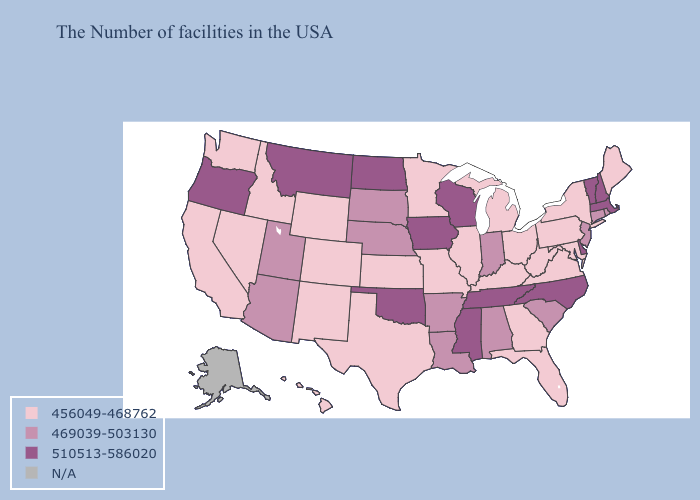Name the states that have a value in the range 510513-586020?
Write a very short answer. Massachusetts, New Hampshire, Vermont, Delaware, North Carolina, Tennessee, Wisconsin, Mississippi, Iowa, Oklahoma, North Dakota, Montana, Oregon. Name the states that have a value in the range 510513-586020?
Short answer required. Massachusetts, New Hampshire, Vermont, Delaware, North Carolina, Tennessee, Wisconsin, Mississippi, Iowa, Oklahoma, North Dakota, Montana, Oregon. Does West Virginia have the lowest value in the USA?
Quick response, please. Yes. Which states hav the highest value in the South?
Keep it brief. Delaware, North Carolina, Tennessee, Mississippi, Oklahoma. Does Minnesota have the lowest value in the MidWest?
Concise answer only. Yes. What is the highest value in the MidWest ?
Short answer required. 510513-586020. What is the value of Oregon?
Concise answer only. 510513-586020. Name the states that have a value in the range 456049-468762?
Concise answer only. Maine, New York, Maryland, Pennsylvania, Virginia, West Virginia, Ohio, Florida, Georgia, Michigan, Kentucky, Illinois, Missouri, Minnesota, Kansas, Texas, Wyoming, Colorado, New Mexico, Idaho, Nevada, California, Washington, Hawaii. What is the value of Oklahoma?
Quick response, please. 510513-586020. What is the value of New York?
Write a very short answer. 456049-468762. Does Nebraska have the lowest value in the USA?
Keep it brief. No. What is the value of New York?
Be succinct. 456049-468762. Name the states that have a value in the range 456049-468762?
Write a very short answer. Maine, New York, Maryland, Pennsylvania, Virginia, West Virginia, Ohio, Florida, Georgia, Michigan, Kentucky, Illinois, Missouri, Minnesota, Kansas, Texas, Wyoming, Colorado, New Mexico, Idaho, Nevada, California, Washington, Hawaii. Which states have the highest value in the USA?
Write a very short answer. Massachusetts, New Hampshire, Vermont, Delaware, North Carolina, Tennessee, Wisconsin, Mississippi, Iowa, Oklahoma, North Dakota, Montana, Oregon. Does Virginia have the highest value in the South?
Answer briefly. No. 